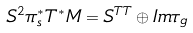Convert formula to latex. <formula><loc_0><loc_0><loc_500><loc_500>S ^ { 2 } \pi _ { s } ^ { * } T ^ { * } M = S ^ { T T } \oplus I m \tau _ { g }</formula> 